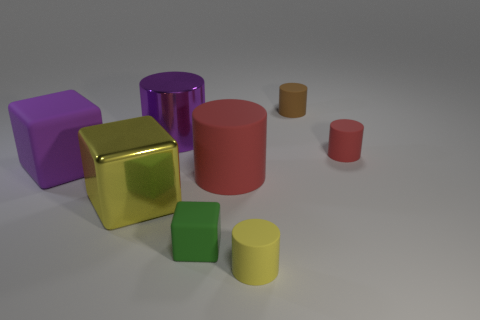Is the purple rubber cube the same size as the yellow cube?
Give a very brief answer. Yes. There is a purple rubber object behind the red cylinder that is on the left side of the tiny yellow matte thing; what is its size?
Offer a very short reply. Large. What is the color of the object that is in front of the purple block and left of the small green rubber block?
Your response must be concise. Yellow. Is the big purple metallic object the same shape as the big red rubber object?
Offer a terse response. Yes. What is the size of the matte object that is the same color as the big shiny cylinder?
Ensure brevity in your answer.  Large. There is a shiny thing that is in front of the large purple rubber object behind the green rubber cube; what is its shape?
Offer a terse response. Cube. There is a green object; is it the same shape as the yellow object to the left of the yellow cylinder?
Provide a short and direct response. Yes. There is another block that is the same size as the purple cube; what is its color?
Your answer should be compact. Yellow. Are there fewer big objects that are behind the brown matte thing than yellow objects that are behind the tiny green rubber block?
Offer a terse response. Yes. What is the shape of the purple metal object that is on the right side of the yellow metal object that is in front of the big shiny thing that is to the right of the yellow cube?
Your response must be concise. Cylinder. 